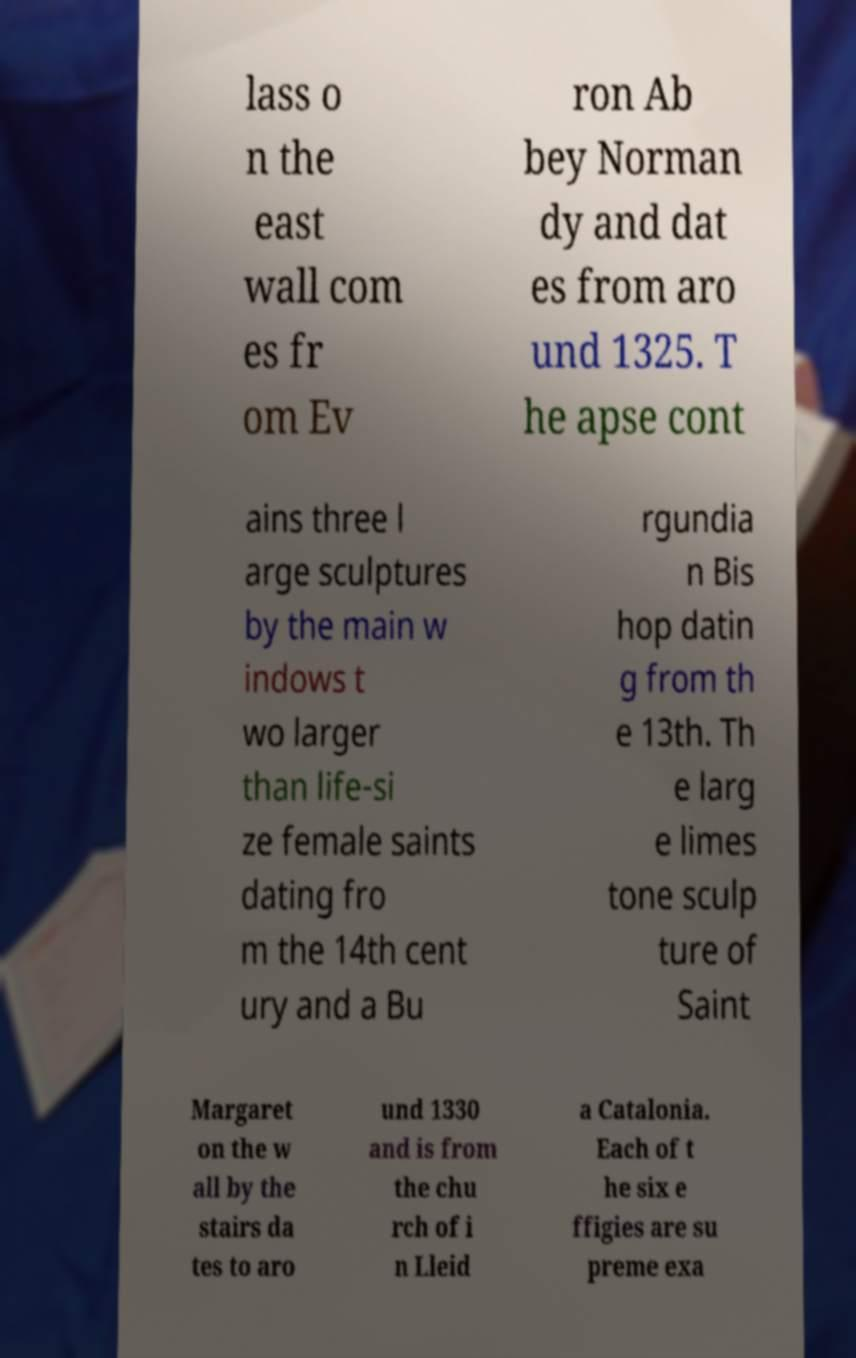Can you accurately transcribe the text from the provided image for me? lass o n the east wall com es fr om Ev ron Ab bey Norman dy and dat es from aro und 1325. T he apse cont ains three l arge sculptures by the main w indows t wo larger than life-si ze female saints dating fro m the 14th cent ury and a Bu rgundia n Bis hop datin g from th e 13th. Th e larg e limes tone sculp ture of Saint Margaret on the w all by the stairs da tes to aro und 1330 and is from the chu rch of i n Lleid a Catalonia. Each of t he six e ffigies are su preme exa 